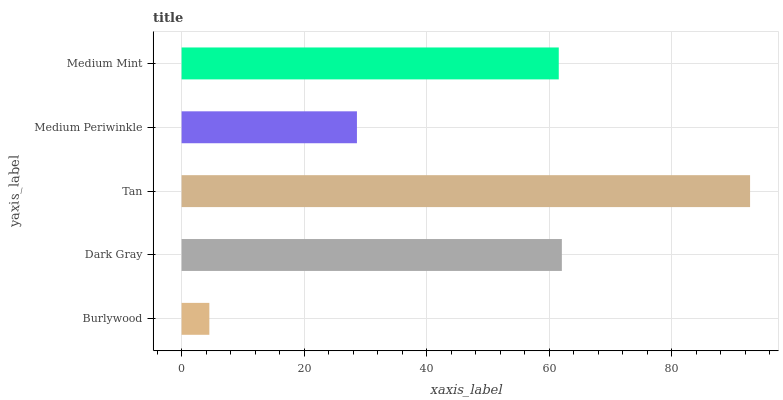Is Burlywood the minimum?
Answer yes or no. Yes. Is Tan the maximum?
Answer yes or no. Yes. Is Dark Gray the minimum?
Answer yes or no. No. Is Dark Gray the maximum?
Answer yes or no. No. Is Dark Gray greater than Burlywood?
Answer yes or no. Yes. Is Burlywood less than Dark Gray?
Answer yes or no. Yes. Is Burlywood greater than Dark Gray?
Answer yes or no. No. Is Dark Gray less than Burlywood?
Answer yes or no. No. Is Medium Mint the high median?
Answer yes or no. Yes. Is Medium Mint the low median?
Answer yes or no. Yes. Is Burlywood the high median?
Answer yes or no. No. Is Burlywood the low median?
Answer yes or no. No. 